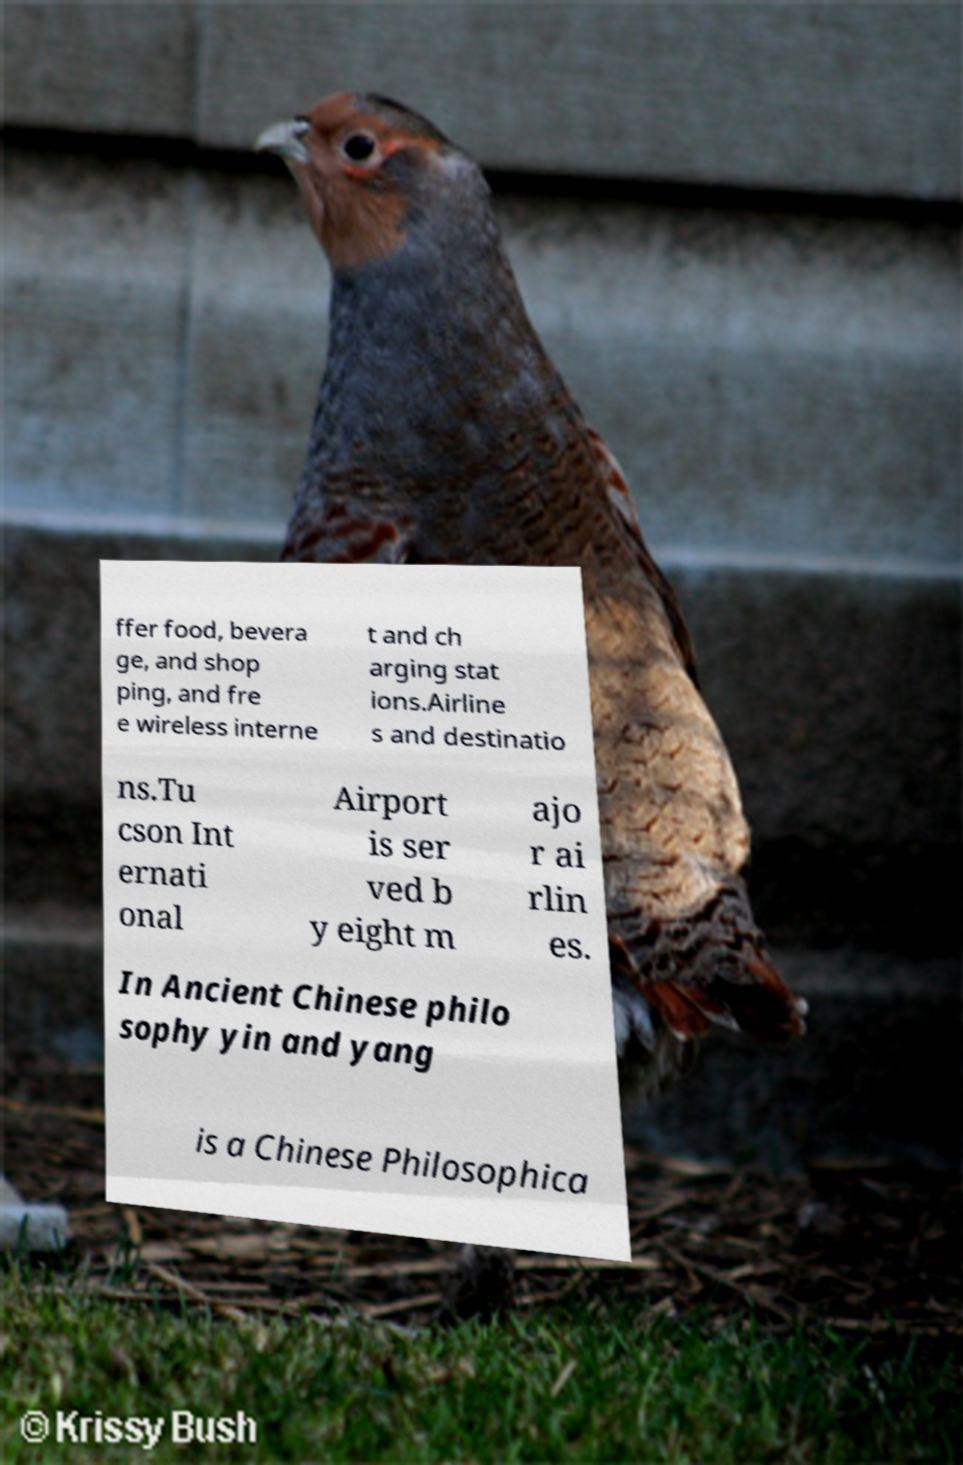Please read and relay the text visible in this image. What does it say? ffer food, bevera ge, and shop ping, and fre e wireless interne t and ch arging stat ions.Airline s and destinatio ns.Tu cson Int ernati onal Airport is ser ved b y eight m ajo r ai rlin es. In Ancient Chinese philo sophy yin and yang is a Chinese Philosophica 